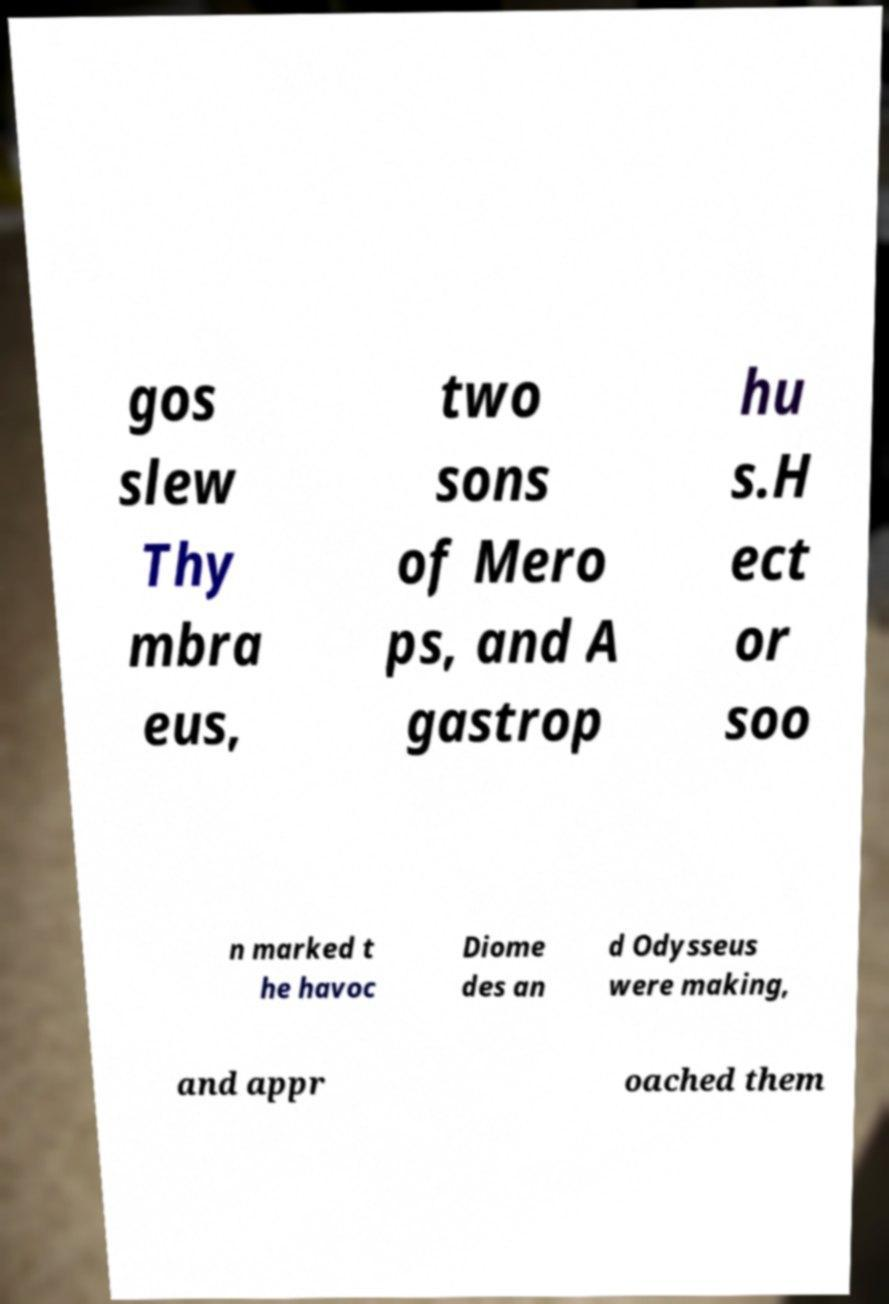I need the written content from this picture converted into text. Can you do that? gos slew Thy mbra eus, two sons of Mero ps, and A gastrop hu s.H ect or soo n marked t he havoc Diome des an d Odysseus were making, and appr oached them 